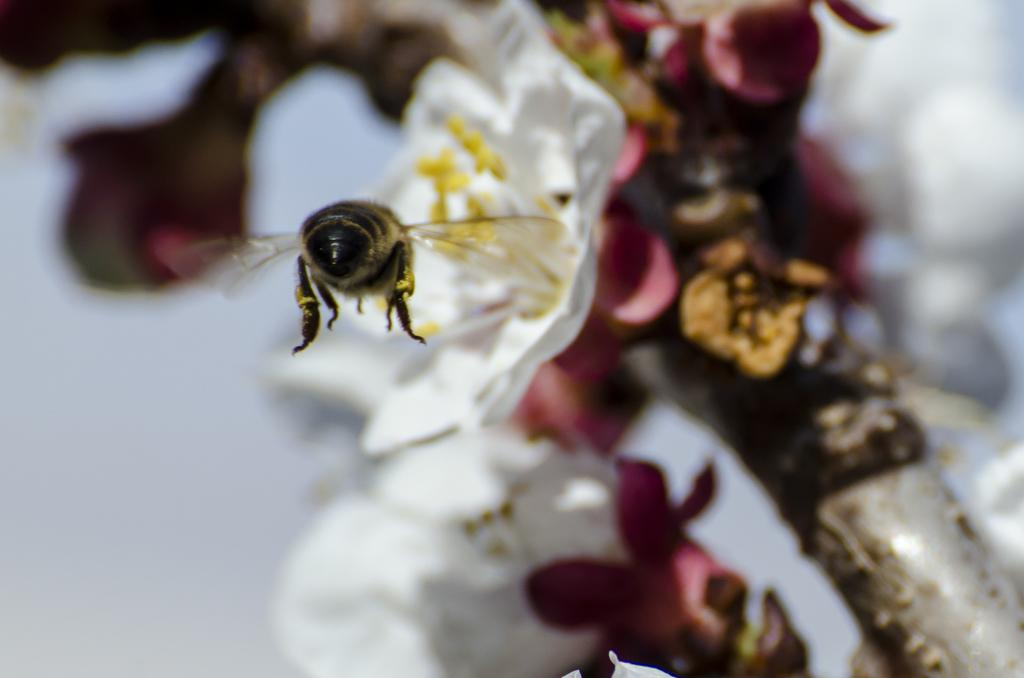What can be seen on the right side of the image? There is a stem with flowers on the right side of the image. What is located in the middle of the image? There is a bee in the middle of the image. How would you describe the background of the image? The background of the image is blurred. Where are the cattle grazing in the image? There are no cattle present in the image. What type of drawer can be seen in the image? There is no drawer present in the image. 